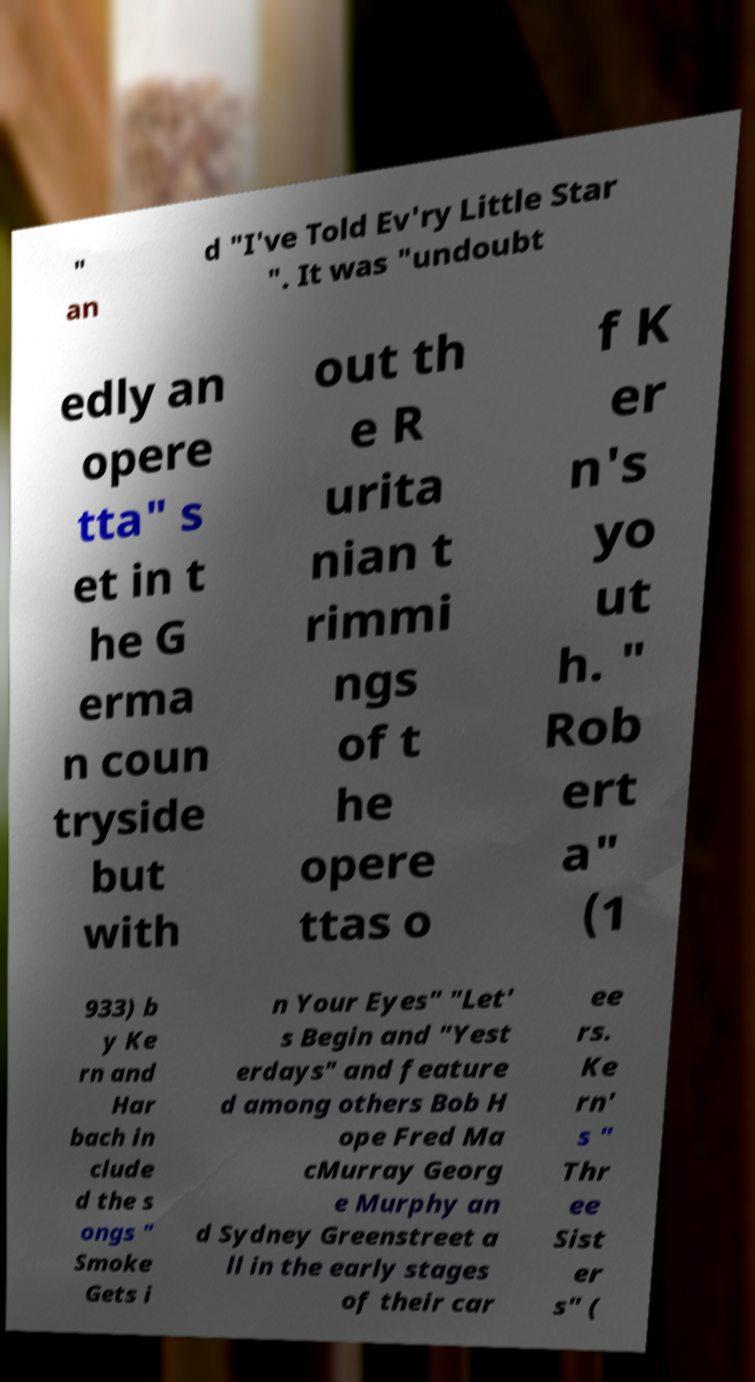Could you assist in decoding the text presented in this image and type it out clearly? " an d "I've Told Ev'ry Little Star ". It was "undoubt edly an opere tta" s et in t he G erma n coun tryside but with out th e R urita nian t rimmi ngs of t he opere ttas o f K er n's yo ut h. " Rob ert a" (1 933) b y Ke rn and Har bach in clude d the s ongs " Smoke Gets i n Your Eyes" "Let' s Begin and "Yest erdays" and feature d among others Bob H ope Fred Ma cMurray Georg e Murphy an d Sydney Greenstreet a ll in the early stages of their car ee rs. Ke rn' s " Thr ee Sist er s" ( 